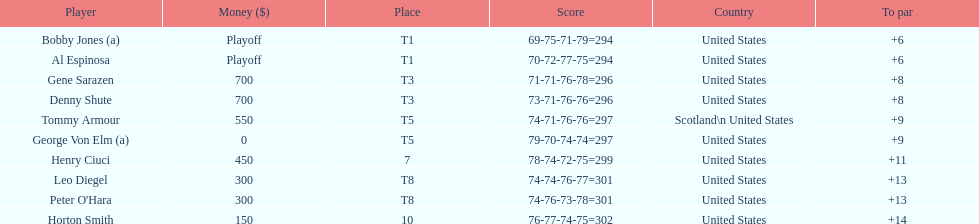Who finished next after bobby jones and al espinosa? Gene Sarazen, Denny Shute. 